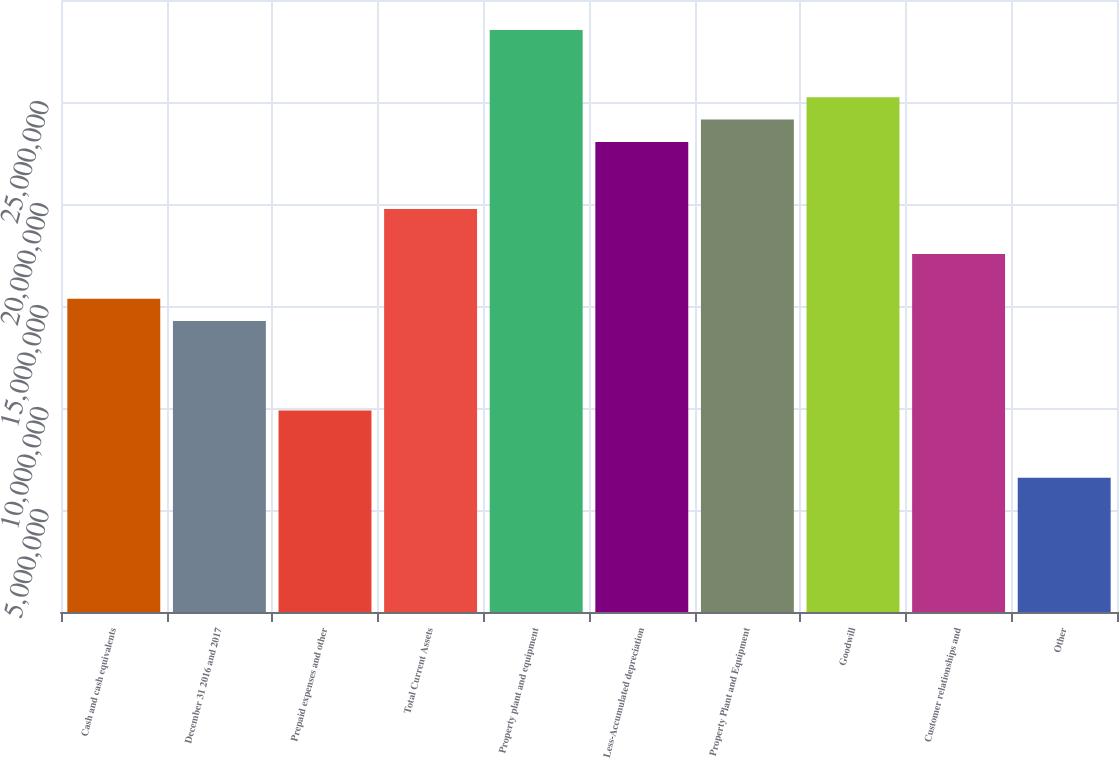<chart> <loc_0><loc_0><loc_500><loc_500><bar_chart><fcel>Cash and cash equivalents<fcel>December 31 2016 and 2017<fcel>Prepaid expenses and other<fcel>Total Current Assets<fcel>Property plant and equipment<fcel>Less-Accumulated depreciation<fcel>Property Plant and Equipment<fcel>Goodwill<fcel>Customer relationships and<fcel>Other<nl><fcel>1.53608e+07<fcel>1.42637e+07<fcel>9.8753e+06<fcel>1.97492e+07<fcel>2.8526e+07<fcel>2.30405e+07<fcel>2.41376e+07<fcel>2.52347e+07<fcel>1.7555e+07<fcel>6.584e+06<nl></chart> 